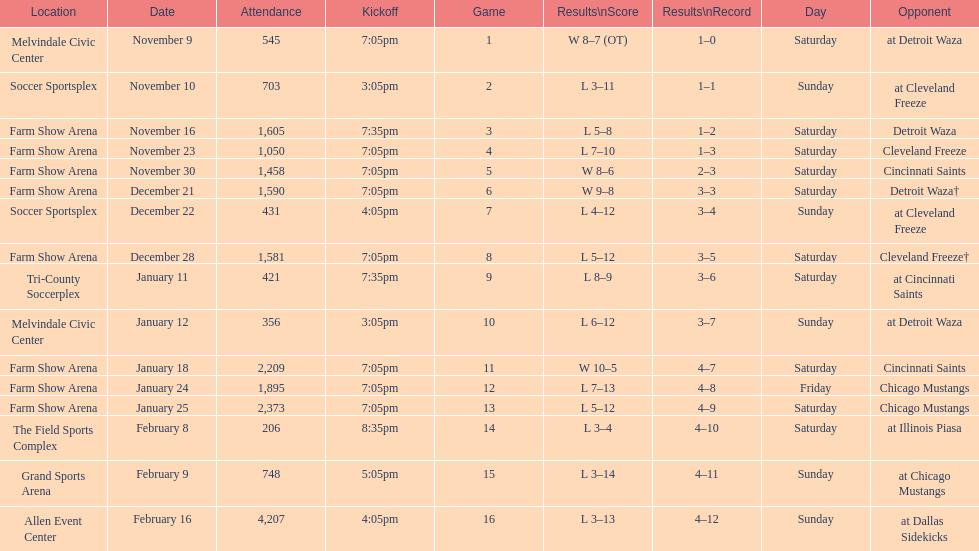How many times did the team play at home but did not win? 5. 